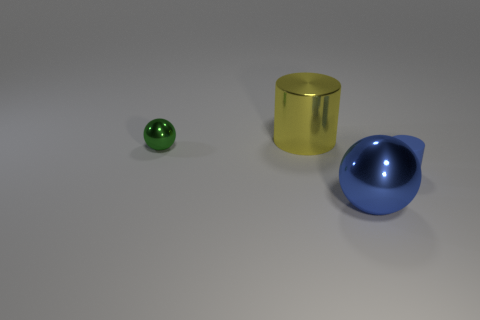Add 4 big metal spheres. How many objects exist? 8 Add 3 big red metallic cylinders. How many big red metallic cylinders exist? 3 Subtract 0 purple spheres. How many objects are left? 4 Subtract all tiny gray rubber cylinders. Subtract all green balls. How many objects are left? 3 Add 3 green metal spheres. How many green metal spheres are left? 4 